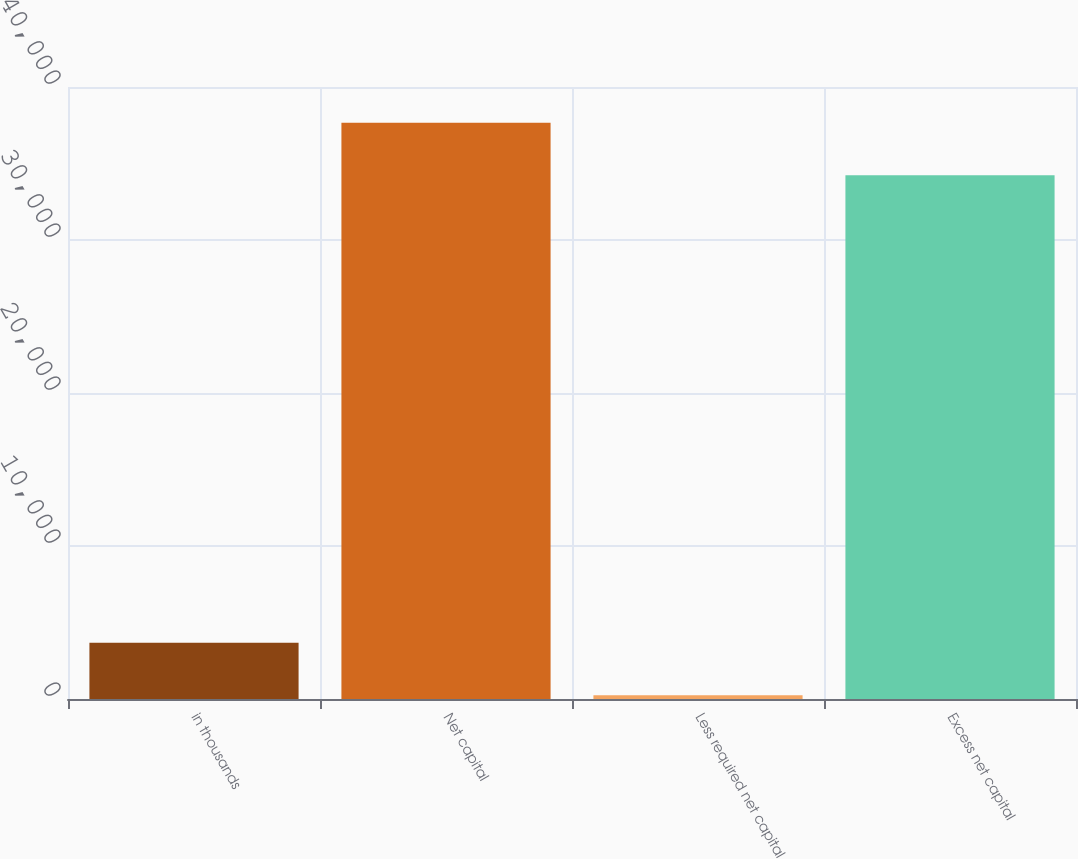<chart> <loc_0><loc_0><loc_500><loc_500><bar_chart><fcel>in thousands<fcel>Net capital<fcel>Less required net capital<fcel>Excess net capital<nl><fcel>3673.8<fcel>37661.8<fcel>250<fcel>34238<nl></chart> 